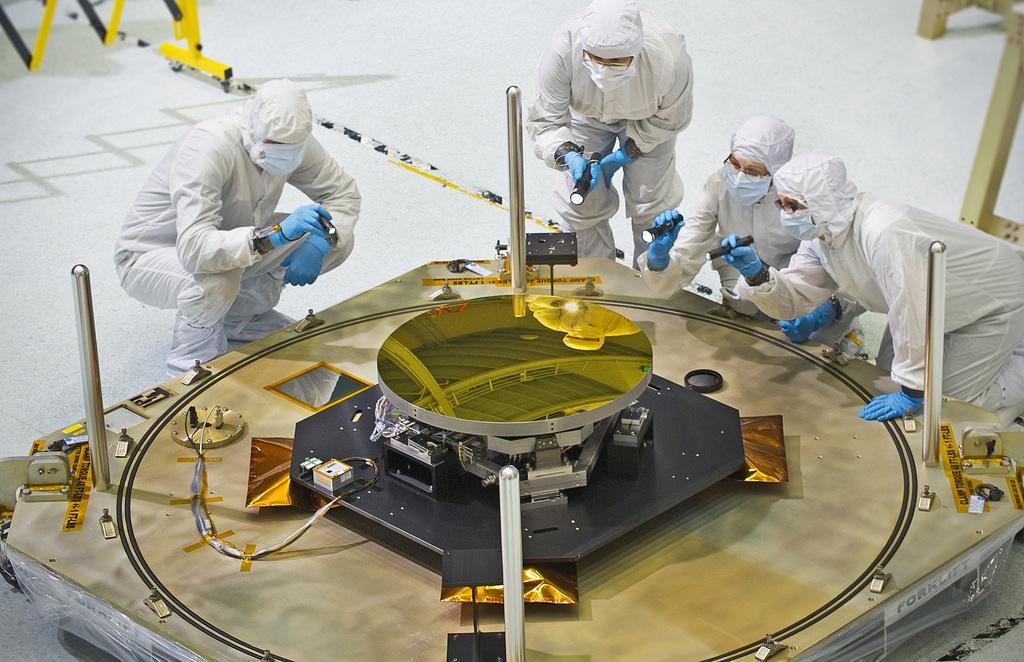Could you give a brief overview of what you see in this image? In this picture we can see one table on it one machine is placed around, few people are sitting and watching. 